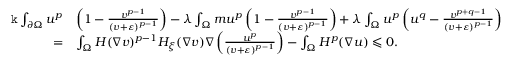Convert formula to latex. <formula><loc_0><loc_0><loc_500><loc_500>\begin{array} { r l } { \mathtt k \int _ { \partial \Omega } u ^ { p } } & { \left ( 1 - \frac { v ^ { p - 1 } } { ( v + \varepsilon ) ^ { p - 1 } } \right ) - \lambda \int _ { \Omega } m u ^ { p } \left ( 1 - \frac { v ^ { p - 1 } } { ( v + \varepsilon ) ^ { p - 1 } } \right ) + \lambda \int _ { \Omega } u ^ { p } \left ( u ^ { q } - \frac { v ^ { p + q - 1 } } { ( v + \varepsilon ) ^ { p - 1 } } \right ) } \\ { = } & { \int _ { \Omega } H ( \nabla v ) ^ { p - 1 } H _ { \xi } ( \nabla v ) \nabla \left ( \frac { u ^ { p } } { ( v + \varepsilon ) ^ { p - 1 } } \right ) - \int _ { \Omega } H ^ { p } ( \nabla u ) \leqslant 0 . } \end{array}</formula> 